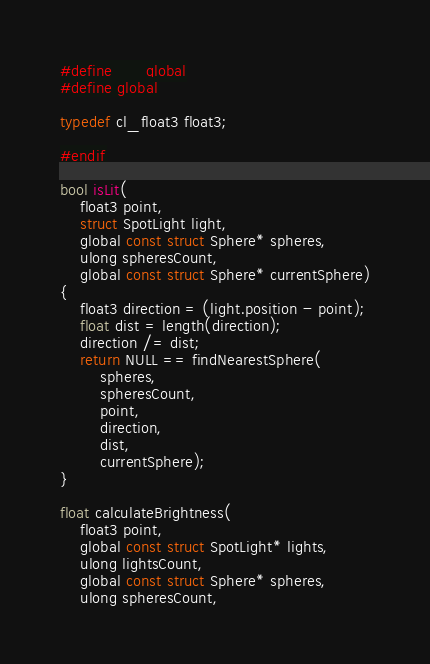<code> <loc_0><loc_0><loc_500><loc_500><_C++_>#define __global
#define global

typedef cl_float3 float3;

#endif

bool isLit(
    float3 point,
    struct SpotLight light,
    global const struct Sphere* spheres,
    ulong spheresCount,
    global const struct Sphere* currentSphere)
{
    float3 direction = (light.position - point);
    float dist = length(direction);
    direction /= dist;
    return NULL == findNearestSphere(
        spheres,
        spheresCount,
        point,
        direction,
        dist,
        currentSphere);
}

float calculateBrightness(
    float3 point,
    global const struct SpotLight* lights,
    ulong lightsCount,
    global const struct Sphere* spheres,
    ulong spheresCount,</code> 